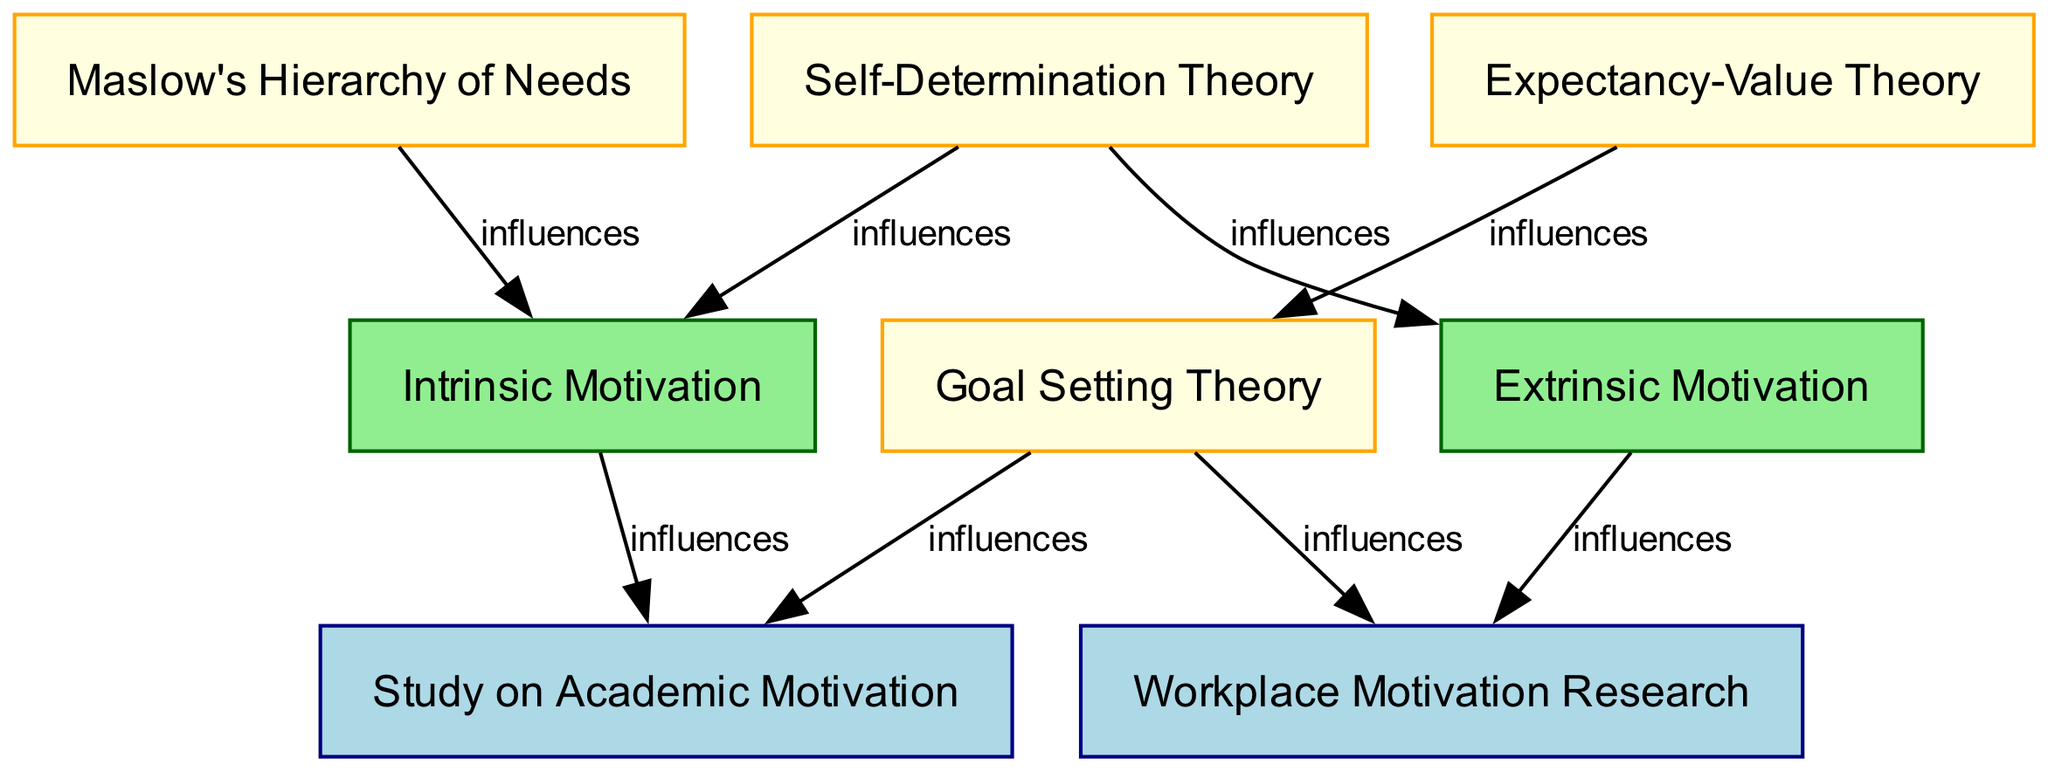What is the total number of nodes in the diagram? The diagram includes eight nodes, which are Maslow's Hierarchy of Needs, Self-Determination Theory, Expectancy-Value Theory, Goal Setting Theory, Intrinsic Motivation, Extrinsic Motivation, Study on Academic Motivation, and Workplace Motivation Research. Counting these gives us a total of eight nodes.
Answer: 8 Which theory influences both intrinsic and extrinsic motivation? In the diagram, Self-Determination Theory has directed edges to both Intrinsic Motivation and Extrinsic Motivation, indicating that it influences both types of motivation.
Answer: Self-Determination Theory How many research studies are connected to Goal Setting Theory? The diagram shows that Goal Setting Theory has directed edges leading to two research studies: Study on Academic Motivation and Workplace Motivation Research. Therefore, it is connected to two research studies.
Answer: 2 Which motivation type is influenced by Maslow's Hierarchy of Needs? The diagram indicates a directed edge from Maslow's Hierarchy of Needs to Intrinsic Motivation, showing that Maslow's theory specifically influences intrinsic motivation.
Answer: Intrinsic Motivation What is the relationship between Expectancy-Value Theory and Goal Setting Theory? According to the diagram, Expectancy-Value Theory has a directed edge leading to Goal Setting Theory, indicating that Expectancy-Value Theory influences Goal Setting Theory.
Answer: influences Which research study is influenced by both Goal Setting Theory and Intrinsic Motivation? In the diagram, the Study on Academic Motivation is influenced by both Goal Setting Theory (indicated by a directed edge) and Intrinsic Motivation (also indicated by a directed edge). Thus, it is linked to both theories.
Answer: Study on Academic Motivation Which type of motivation is only influenced by Self-Determination Theory? The diagram shows that Self-Determination Theory influences both Intrinsic Motivation and Extrinsic Motivation, but only Intrinsic Motivation is uniquely connected to this theory without dependencies on others. Therefore, it can be inferred from the structure that while both types are influenced, the context emphasizes Intrinsic Motivation as being closely tied to Self-Determination Theory.
Answer: Intrinsic Motivation How many total edges are present in the diagram? The diagram illustrates seven directed connections (edges) between various nodes, specifically detailing influences among the theories and studies. By counting these edges, we arrive at a total of seven.
Answer: 7 Which theory is linked to both research studies? The diagram specifies that Goal Setting Theory influences both Study on Academic Motivation and Workplace Motivation Research, making it the common link. Thus, Goal Setting Theory is the theory that connects to both research studies.
Answer: Goal Setting Theory 